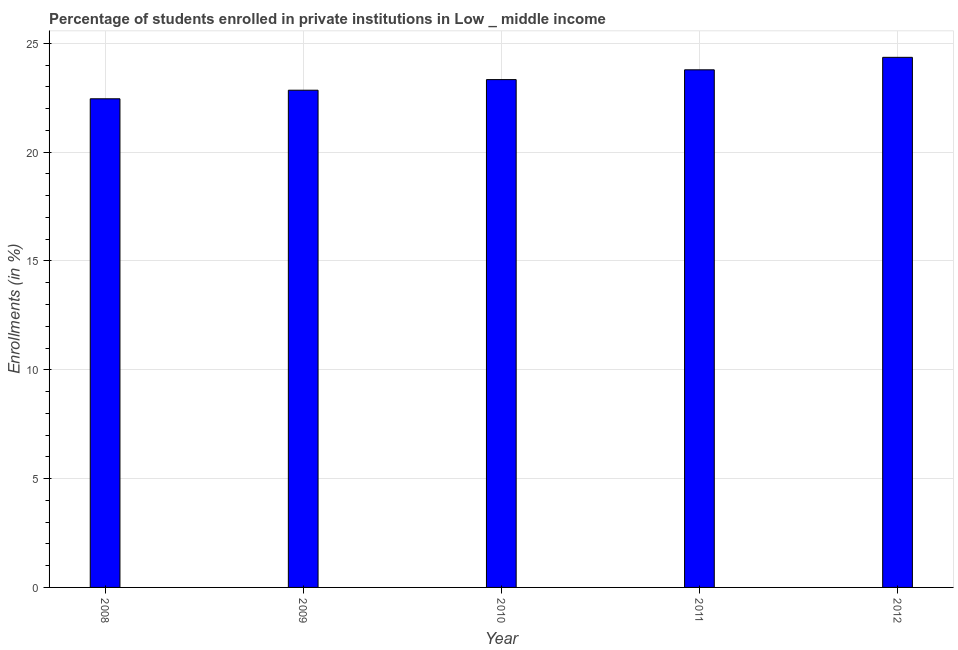Does the graph contain grids?
Make the answer very short. Yes. What is the title of the graph?
Offer a very short reply. Percentage of students enrolled in private institutions in Low _ middle income. What is the label or title of the X-axis?
Your answer should be compact. Year. What is the label or title of the Y-axis?
Make the answer very short. Enrollments (in %). What is the enrollments in private institutions in 2011?
Your response must be concise. 23.78. Across all years, what is the maximum enrollments in private institutions?
Make the answer very short. 24.36. Across all years, what is the minimum enrollments in private institutions?
Offer a very short reply. 22.45. In which year was the enrollments in private institutions maximum?
Offer a terse response. 2012. In which year was the enrollments in private institutions minimum?
Your response must be concise. 2008. What is the sum of the enrollments in private institutions?
Keep it short and to the point. 116.77. What is the difference between the enrollments in private institutions in 2008 and 2009?
Provide a short and direct response. -0.39. What is the average enrollments in private institutions per year?
Your answer should be very brief. 23.35. What is the median enrollments in private institutions?
Your response must be concise. 23.33. In how many years, is the enrollments in private institutions greater than 22 %?
Your answer should be compact. 5. Do a majority of the years between 2009 and 2012 (inclusive) have enrollments in private institutions greater than 15 %?
Keep it short and to the point. Yes. What is the ratio of the enrollments in private institutions in 2008 to that in 2012?
Provide a succinct answer. 0.92. Is the difference between the enrollments in private institutions in 2008 and 2009 greater than the difference between any two years?
Ensure brevity in your answer.  No. What is the difference between the highest and the second highest enrollments in private institutions?
Your answer should be compact. 0.57. Is the sum of the enrollments in private institutions in 2009 and 2011 greater than the maximum enrollments in private institutions across all years?
Ensure brevity in your answer.  Yes. What is the difference between the highest and the lowest enrollments in private institutions?
Provide a succinct answer. 1.91. How many bars are there?
Your answer should be very brief. 5. Are all the bars in the graph horizontal?
Your answer should be compact. No. What is the difference between two consecutive major ticks on the Y-axis?
Your answer should be compact. 5. What is the Enrollments (in %) in 2008?
Provide a succinct answer. 22.45. What is the Enrollments (in %) in 2009?
Your response must be concise. 22.85. What is the Enrollments (in %) in 2010?
Your response must be concise. 23.33. What is the Enrollments (in %) of 2011?
Give a very brief answer. 23.78. What is the Enrollments (in %) of 2012?
Provide a succinct answer. 24.36. What is the difference between the Enrollments (in %) in 2008 and 2009?
Give a very brief answer. -0.39. What is the difference between the Enrollments (in %) in 2008 and 2010?
Ensure brevity in your answer.  -0.88. What is the difference between the Enrollments (in %) in 2008 and 2011?
Give a very brief answer. -1.33. What is the difference between the Enrollments (in %) in 2008 and 2012?
Offer a very short reply. -1.91. What is the difference between the Enrollments (in %) in 2009 and 2010?
Provide a short and direct response. -0.49. What is the difference between the Enrollments (in %) in 2009 and 2011?
Keep it short and to the point. -0.94. What is the difference between the Enrollments (in %) in 2009 and 2012?
Your response must be concise. -1.51. What is the difference between the Enrollments (in %) in 2010 and 2011?
Offer a terse response. -0.45. What is the difference between the Enrollments (in %) in 2010 and 2012?
Provide a succinct answer. -1.02. What is the difference between the Enrollments (in %) in 2011 and 2012?
Your response must be concise. -0.57. What is the ratio of the Enrollments (in %) in 2008 to that in 2010?
Offer a very short reply. 0.96. What is the ratio of the Enrollments (in %) in 2008 to that in 2011?
Ensure brevity in your answer.  0.94. What is the ratio of the Enrollments (in %) in 2008 to that in 2012?
Provide a succinct answer. 0.92. What is the ratio of the Enrollments (in %) in 2009 to that in 2010?
Give a very brief answer. 0.98. What is the ratio of the Enrollments (in %) in 2009 to that in 2012?
Your answer should be compact. 0.94. What is the ratio of the Enrollments (in %) in 2010 to that in 2011?
Provide a succinct answer. 0.98. What is the ratio of the Enrollments (in %) in 2010 to that in 2012?
Keep it short and to the point. 0.96. What is the ratio of the Enrollments (in %) in 2011 to that in 2012?
Offer a very short reply. 0.98. 